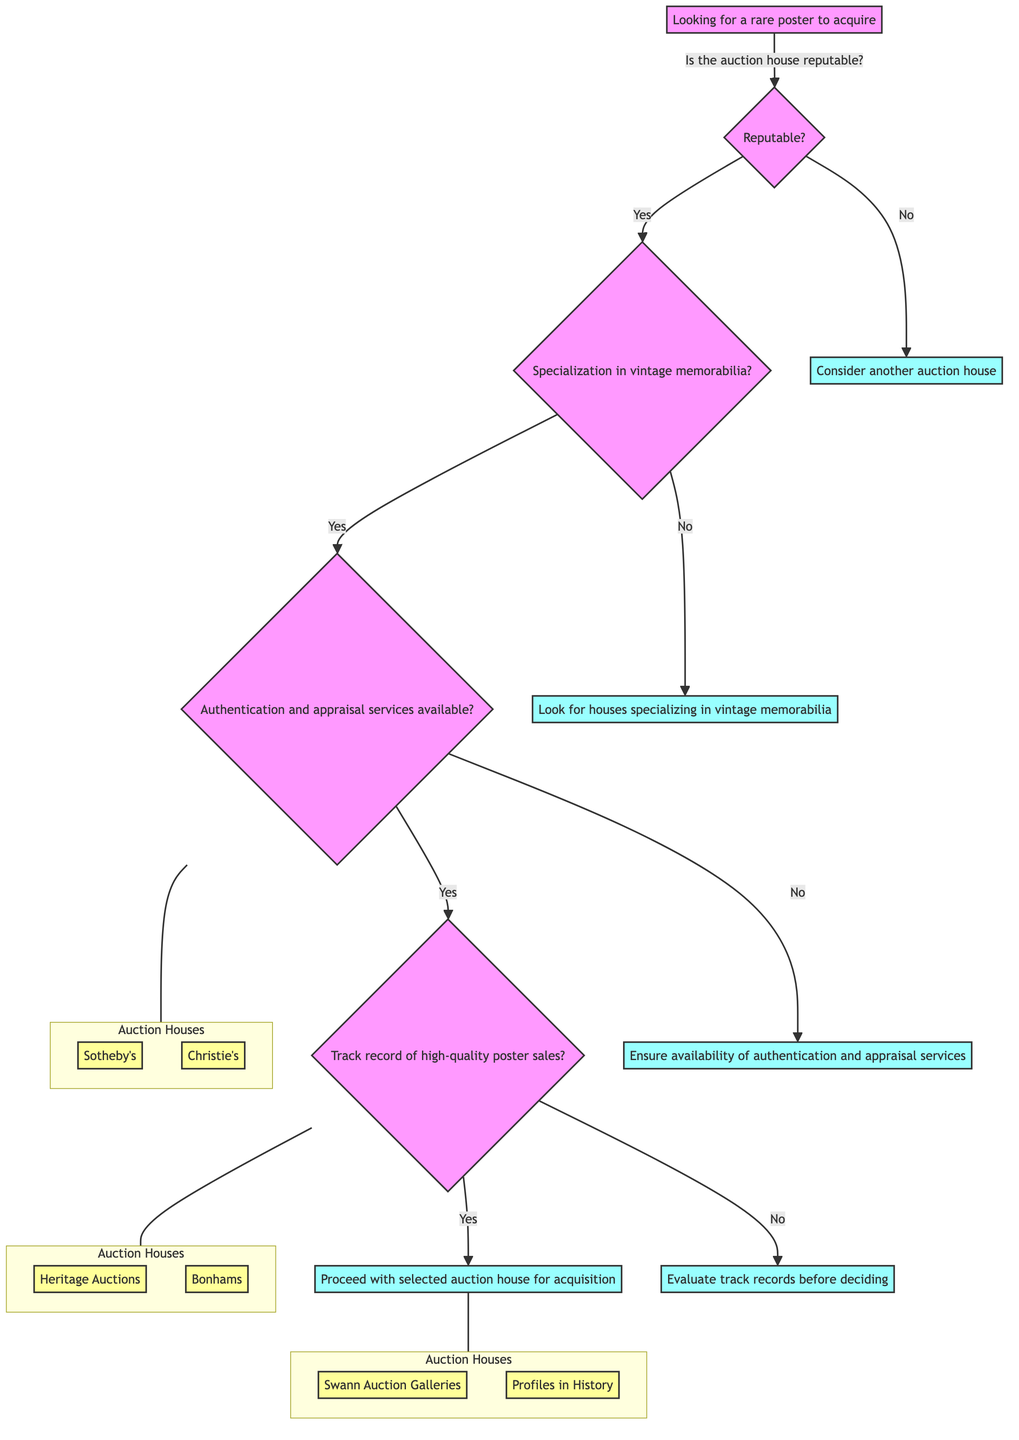What is the starting point of the decision tree? The decision tree starts with the node "Looking for a rare poster to acquire." This is the root node from which all other decisions branch out.
Answer: Looking for a rare poster to acquire How many auction houses are listed under the reputable category? There are four auction houses listed as options under the reputable category after considering specialization in vintage memorabilia and services. The options are Sotheby's, Christie's, Heritage Auctions, and Bonhams.
Answer: Four What should one do if the auction house is not reputable? If the auction house is not reputable, the conclusion is to "Consider another auction house," which means you should look for a different auction house that has a better reputation.
Answer: Consider another auction house What happens if the auction house does not offer authentication and appraisal services? If the auction house does not offer authentication and appraisal services, the conclusion is to "Ensure availability of authentication and appraisal services," meaning one should look for houses that do provide these services before proceeding.
Answer: Ensure availability of authentication and appraisal services Which auction house specializes in vintage posters? Swann Auction Galleries specializes in vintage posters, as indicated by its description in the diagram. This is a clear benefit if one is specifically looking to acquire vintage posters.
Answer: Swann Auction Galleries What step should be taken if an auction house does not have a track record of high-quality poster sales? If an auction house does not have a track record of high-quality poster sales, the next step is to "Evaluate track records before deciding." This suggests a careful consideration of past sales before proceeding.
Answer: Evaluate track records before deciding What are the pros of Sotheby's? The pros of Sotheby's include "High reputation," "Global reach," and "Frequent auctions." Each of these factors contributes to its favorable consideration as an auction house for rare posters.
Answer: High reputation, Global reach, Frequent auctions How many conclusions are presented in the diagram? The diagram presents a total of four conclusions at various decision paths, guiding the user based on the options selected throughout the decision-making process.
Answer: Four What should one do if the auction house specializes more in Hollywood memorabilia? If the auction house specializes more in Hollywood memorabilia, it is advised to "Evaluate track records before deciding," signaling that it may not be the best fit for vintage posters.
Answer: Evaluate track records before deciding 